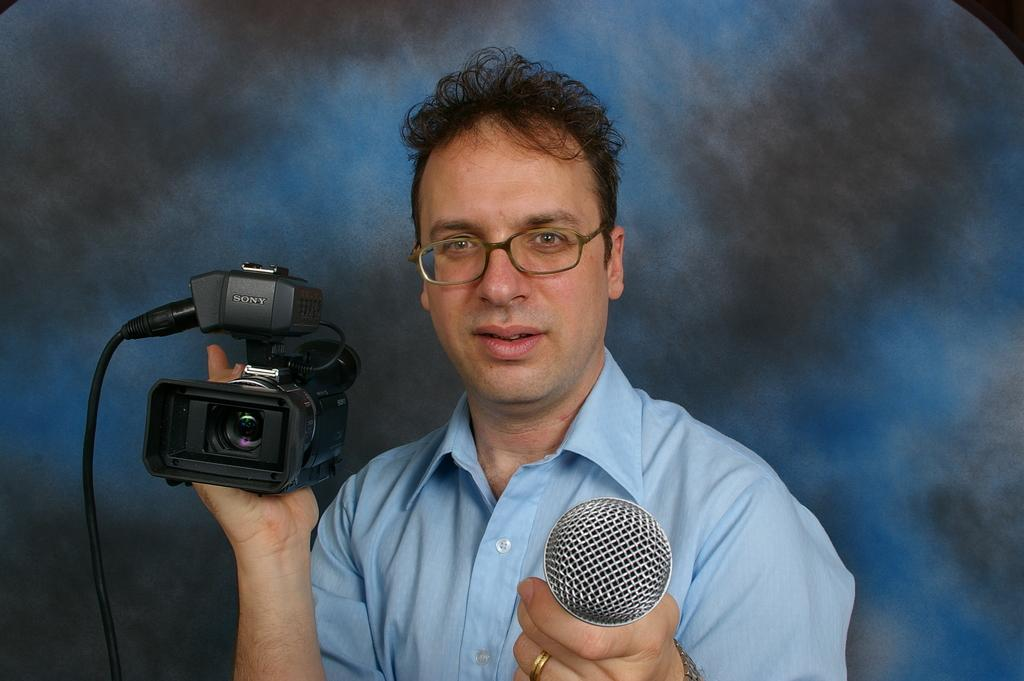What is the man in the image holding in his hand? The man is holding a microphone and a camera in his hand. What might the man be doing in the image? The man might be recording or taking pictures while speaking into the microphone. How many clocks can be seen in the image? There are no clocks visible in the image. What type of agreement is the man discussing in the image? There is no indication of any agreement being discussed in the image. 